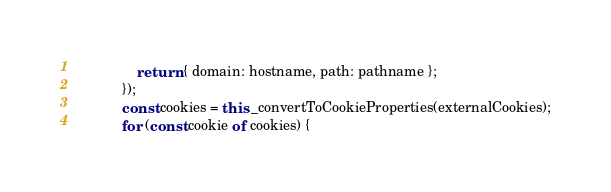Convert code to text. <code><loc_0><loc_0><loc_500><loc_500><_JavaScript_>                return { domain: hostname, path: pathname };
            });
            const cookies = this._convertToCookieProperties(externalCookies);
            for (const cookie of cookies) {</code> 